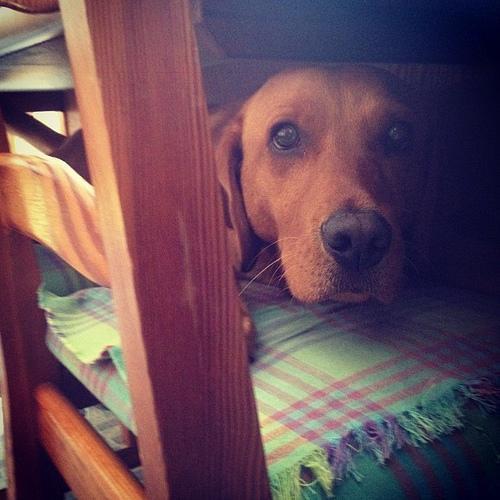How many dogs are there?
Give a very brief answer. 1. 